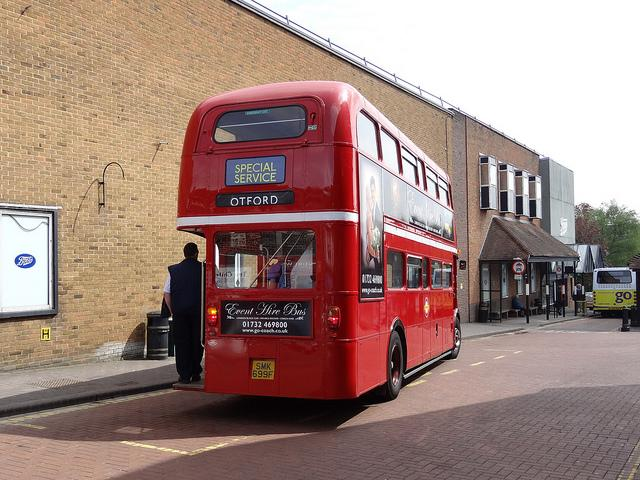What word is written before service?

Choices:
A) out of
B) special
C) secret
D) in special 